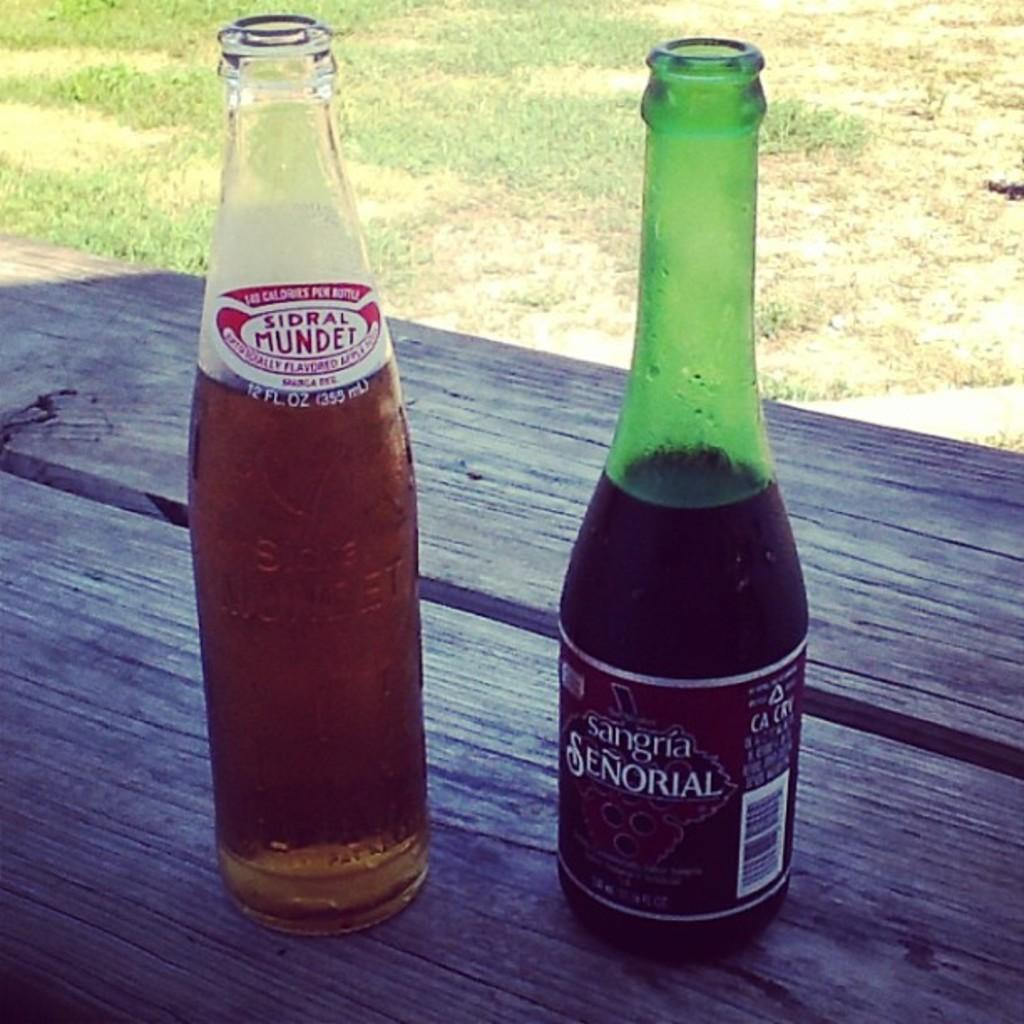Provide a one-sentence caption for the provided image. Bottle with a label that says Senorial on it. 